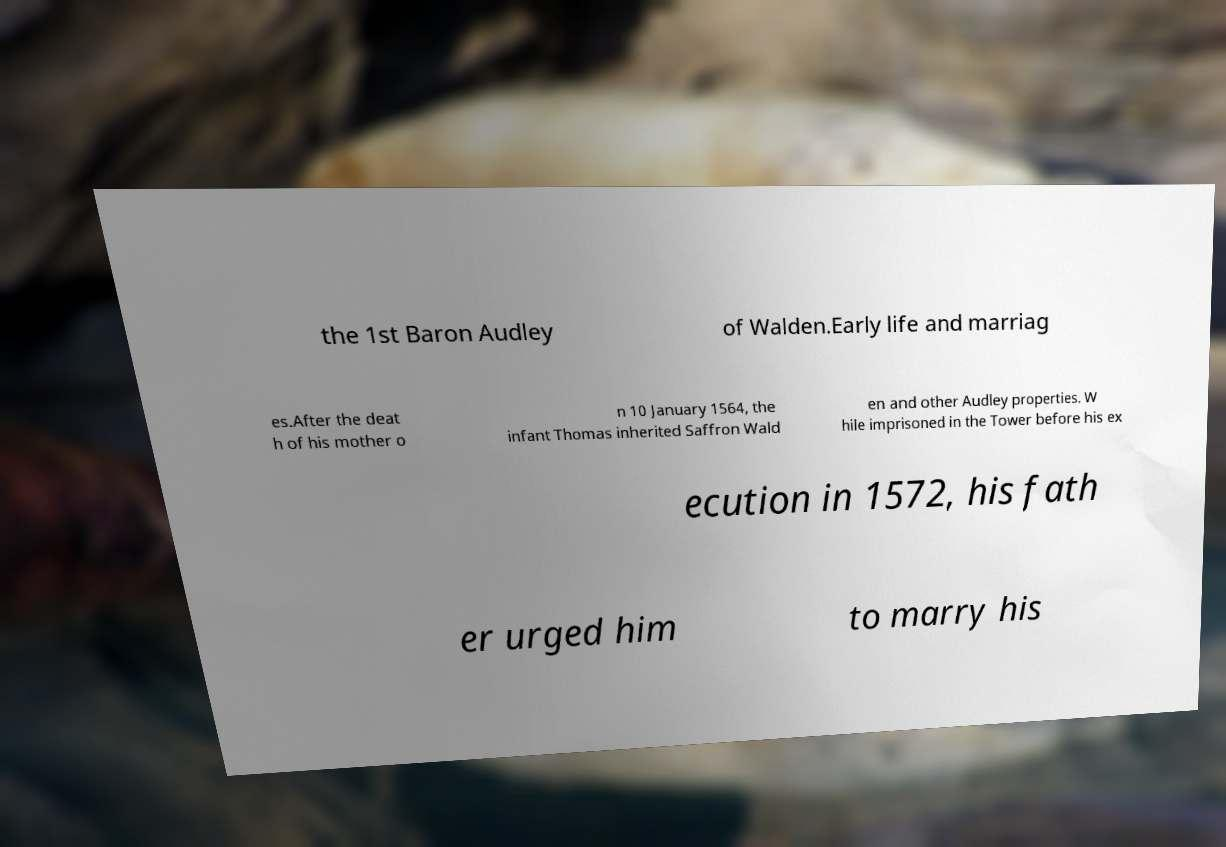There's text embedded in this image that I need extracted. Can you transcribe it verbatim? the 1st Baron Audley of Walden.Early life and marriag es.After the deat h of his mother o n 10 January 1564, the infant Thomas inherited Saffron Wald en and other Audley properties. W hile imprisoned in the Tower before his ex ecution in 1572, his fath er urged him to marry his 